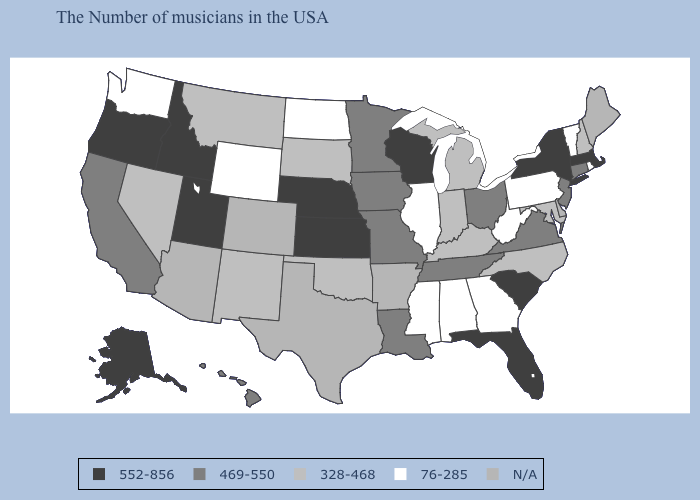Name the states that have a value in the range 469-550?
Be succinct. Connecticut, New Jersey, Virginia, Ohio, Tennessee, Louisiana, Missouri, Minnesota, Iowa, California, Hawaii. What is the highest value in states that border Rhode Island?
Write a very short answer. 552-856. Does Washington have the highest value in the USA?
Quick response, please. No. Which states have the highest value in the USA?
Quick response, please. Massachusetts, New York, South Carolina, Florida, Wisconsin, Kansas, Nebraska, Utah, Idaho, Oregon, Alaska. What is the value of Virginia?
Give a very brief answer. 469-550. What is the value of Illinois?
Quick response, please. 76-285. Does the map have missing data?
Keep it brief. Yes. What is the lowest value in the South?
Concise answer only. 76-285. What is the value of Rhode Island?
Answer briefly. 76-285. Name the states that have a value in the range 469-550?
Answer briefly. Connecticut, New Jersey, Virginia, Ohio, Tennessee, Louisiana, Missouri, Minnesota, Iowa, California, Hawaii. What is the value of Ohio?
Be succinct. 469-550. Which states have the lowest value in the West?
Give a very brief answer. Wyoming, Washington. What is the lowest value in states that border Ohio?
Quick response, please. 76-285. 